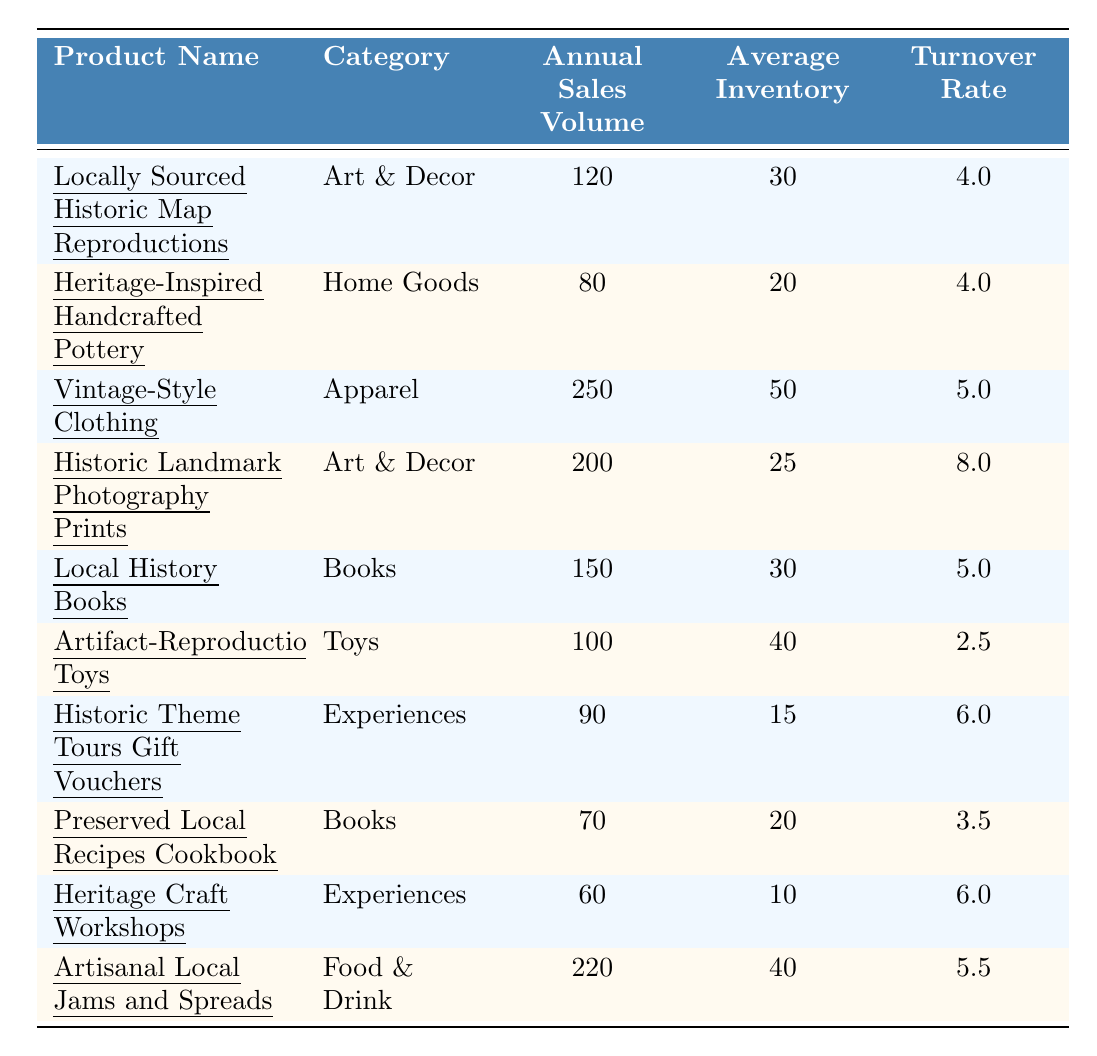What is the turnover rate for "Locally Sourced Historic Map Reproductions"? The turnover rate is listed directly in the table under the corresponding product row, which shows it as 4.0.
Answer: 4.0 Which product has the highest annual sales volume? Looking at the annual sales volume column, "Vintage-Style Clothing" has the highest value of 250.
Answer: Vintage-Style Clothing What is the average turnover rate for the "Books" category? The turnover rates for books are 5.0 for "Local History Books" and 3.5 for "Preserved Local Recipes Cookbook". To find the average, sum these values (5.0 + 3.5) = 8.5 and divide by 2, giving an average of 4.25.
Answer: 4.25 How many products have a turnover rate greater than 5.0? Checking the turnover rates, "Vintage-Style Clothing" (5.0), "Historic Landmark Photography Prints" (8.0), "Historic Theme Tours Gift Vouchers" (6.0), "Heritage Craft Workshops" (6.0), and "Artisanal Local Jams and Spreads" (5.5) fit the criteria. That sums to three products.
Answer: 3 Which product has the lowest turnover rate and what is the rate? The product with the lowest turnover rate is "Artifact-Reproduction Toys," with a rate of 2.5.
Answer: 2.5, Artifact-Reproduction Toys Is the turnover rate higher for "Experiences" or "Home Goods"? "Experiences" includes two products ("Historic Theme Tours Gift Vouchers" with a turnover rate of 6.0 and "Heritage Craft Workshops" with a turnover rate of 6.0), averaging 6.0. "Home Goods" has one product, "Heritage-Inspired Handcrafted Pottery," with a rate of 4.0. Thus, "Experiences" have a higher turnover rate.
Answer: Yes Calculate the total sales volume for "Art & Decor" products. The annual sales volumes for "Art & Decor" are 120 for "Locally Sourced Historic Map Reproductions" and 200 for "Historic Landmark Photography Prints." Adding these gives 120 + 200 = 320.
Answer: 320 What percentage of products have a turnover rate of 4.0? There are ten products total; three have a turnover rate of 4.0 ("Locally Sourced Historic Map Reproductions," "Heritage-Inspired Handcrafted Pottery," and "Vintage-Style Clothing"). Therefore, (3/10) * 100 = 30%.
Answer: 30% Which category has the highest average inventory? Calculating the average inventory for each category: "Art & Decor" (average 27.5), "Home Goods" (20), "Apparel" (50), "Books" (25), "Toys" (40), "Experiences" (12.5), "Food & Drink" (40). The highest average is from "Apparel" at 50.
Answer: Apparel Are there more products with a turnover rate below 4.0 or above? Counting, there are 2 products below 4.0 ("Artifact-Reproduction Toys" and "Preserved Local Recipes Cookbook") and 5 products above 4.0. Therefore, there are more products above 4.0.
Answer: Above 